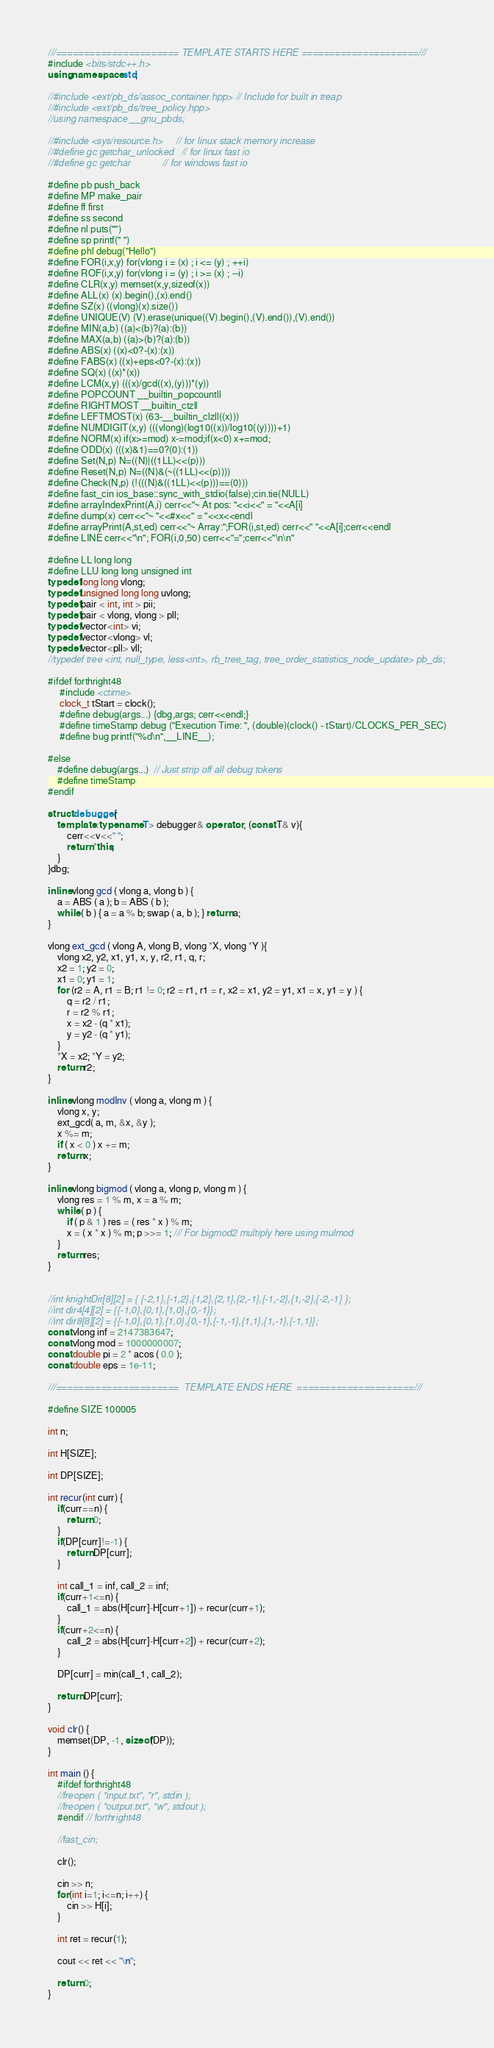Convert code to text. <code><loc_0><loc_0><loc_500><loc_500><_C++_>///====================== TEMPLATE STARTS HERE =====================///
#include <bits/stdc++.h>
using namespace std;

//#include <ext/pb_ds/assoc_container.hpp> // Include for built in treap
//#include <ext/pb_ds/tree_policy.hpp>
//using namespace __gnu_pbds;

//#include <sys/resource.h>     // for linux stack memory increase
//#define gc getchar_unlocked   // for linux fast io
//#define gc getchar            // for windows fast io

#define pb push_back
#define MP make_pair
#define ff first
#define ss second
#define nl puts("")
#define sp printf(" ")
#define phl debug("Hello")
#define FOR(i,x,y) for(vlong i = (x) ; i <= (y) ; ++i)
#define ROF(i,x,y) for(vlong i = (y) ; i >= (x) ; --i)
#define CLR(x,y) memset(x,y,sizeof(x))
#define ALL(x) (x).begin(),(x).end()
#define SZ(x) ((vlong)(x).size())
#define UNIQUE(V) (V).erase(unique((V).begin(),(V).end()),(V).end())
#define MIN(a,b) ((a)<(b)?(a):(b))
#define MAX(a,b) ((a)>(b)?(a):(b))
#define ABS(x) ((x)<0?-(x):(x))
#define FABS(x) ((x)+eps<0?-(x):(x))
#define SQ(x) ((x)*(x))
#define LCM(x,y) (((x)/gcd((x),(y)))*(y))
#define POPCOUNT __builtin_popcountll
#define RIGHTMOST __builtin_ctzll
#define LEFTMOST(x) (63-__builtin_clzll((x)))
#define NUMDIGIT(x,y) (((vlong)(log10((x))/log10((y))))+1)
#define NORM(x) if(x>=mod) x-=mod;if(x<0) x+=mod;
#define ODD(x) (((x)&1)==0?(0):(1))
#define Set(N,p) N=((N)|((1LL)<<(p)))
#define Reset(N,p) N=((N)&(~((1LL)<<(p))))
#define Check(N,p) (!(((N)&((1LL)<<(p)))==(0)))
#define fast_cin ios_base::sync_with_stdio(false);cin.tie(NULL)
#define arrayIndexPrint(A,i) cerr<<"~ At pos: "<<i<<" = "<<A[i]
#define dump(x) cerr<<"~ "<<#x<<" = "<<x<<endl
#define arrayPrint(A,st,ed) cerr<<"~ Array:";FOR(i,st,ed) cerr<<" "<<A[i];cerr<<endl
#define LINE cerr<<"\n"; FOR(i,0,50) cerr<<"=";cerr<<"\n\n"

#define LL long long
#define LLU long long unsigned int
typedef long long vlong;
typedef unsigned long long uvlong;
typedef pair < int, int > pii;
typedef pair < vlong, vlong > pll;
typedef vector<int> vi;
typedef vector<vlong> vl;
typedef vector<pll> vll;
//typedef tree <int, null_type, less<int>, rb_tree_tag, tree_order_statistics_node_update> pb_ds;

#ifdef forthright48
     #include <ctime>
     clock_t tStart = clock();
     #define debug(args...) {dbg,args; cerr<<endl;}
     #define timeStamp debug ("Execution Time: ", (double)(clock() - tStart)/CLOCKS_PER_SEC)
     #define bug printf("%d\n",__LINE__);

#else
    #define debug(args...)  // Just strip off all debug tokens
    #define timeStamp
#endif

struct debugger{
    template<typename T> debugger& operator , (const T& v){
        cerr<<v<<" ";
        return *this;
    }
}dbg;

inline vlong gcd ( vlong a, vlong b ) {
    a = ABS ( a ); b = ABS ( b );
    while ( b ) { a = a % b; swap ( a, b ); } return a;
}

vlong ext_gcd ( vlong A, vlong B, vlong *X, vlong *Y ){
    vlong x2, y2, x1, y1, x, y, r2, r1, q, r;
    x2 = 1; y2 = 0;
    x1 = 0; y1 = 1;
    for (r2 = A, r1 = B; r1 != 0; r2 = r1, r1 = r, x2 = x1, y2 = y1, x1 = x, y1 = y ) {
        q = r2 / r1;
        r = r2 % r1;
        x = x2 - (q * x1);
        y = y2 - (q * y1);
    }
    *X = x2; *Y = y2;
    return r2;
}

inline vlong modInv ( vlong a, vlong m ) {
    vlong x, y;
    ext_gcd( a, m, &x, &y );
    x %= m;
    if ( x < 0 ) x += m;
    return x;
}

inline vlong bigmod ( vlong a, vlong p, vlong m ) {
    vlong res = 1 % m, x = a % m;
    while ( p ) {
        if ( p & 1 ) res = ( res * x ) % m;
        x = ( x * x ) % m; p >>= 1; /// For bigmod2 multiply here using mulmod
    }
    return res;
}


//int knightDir[8][2] = { {-2,1},{-1,2},{1,2},{2,1},{2,-1},{-1,-2},{1,-2},{-2,-1} };
//int dir4[4][2] = {{-1,0},{0,1},{1,0},{0,-1}};
//int dir8[8][2] = {{-1,0},{0,1},{1,0},{0,-1},{-1,-1},{1,1},{1,-1},{-1,1}};
const vlong inf = 2147383647;
const vlong mod = 1000000007;
const double pi = 2 * acos ( 0.0 );
const double eps = 1e-11;

///======================  TEMPLATE ENDS HERE  =====================///

#define SIZE 100005

int n;

int H[SIZE];

int DP[SIZE];

int recur(int curr) {
    if(curr==n) {
        return 0;
    }
    if(DP[curr]!=-1) {
        return DP[curr];
    }

    int call_1 = inf, call_2 = inf;
    if(curr+1<=n) {
        call_1 = abs(H[curr]-H[curr+1]) + recur(curr+1);
    }
    if(curr+2<=n) {
        call_2 = abs(H[curr]-H[curr+2]) + recur(curr+2);
    }

    DP[curr] = min(call_1, call_2);

    return DP[curr];
}

void clr() {
    memset(DP, -1, sizeof(DP));
}

int main () {
    #ifdef forthright48
    //freopen ( "input.txt", "r", stdin );
    //freopen ( "output.txt", "w", stdout );
    #endif // forthright48

    //fast_cin;

    clr();

    cin >> n;
    for(int i=1; i<=n; i++) {
        cin >> H[i];
    }

    int ret = recur(1);

    cout << ret << "\n";

    return 0;
}



</code> 